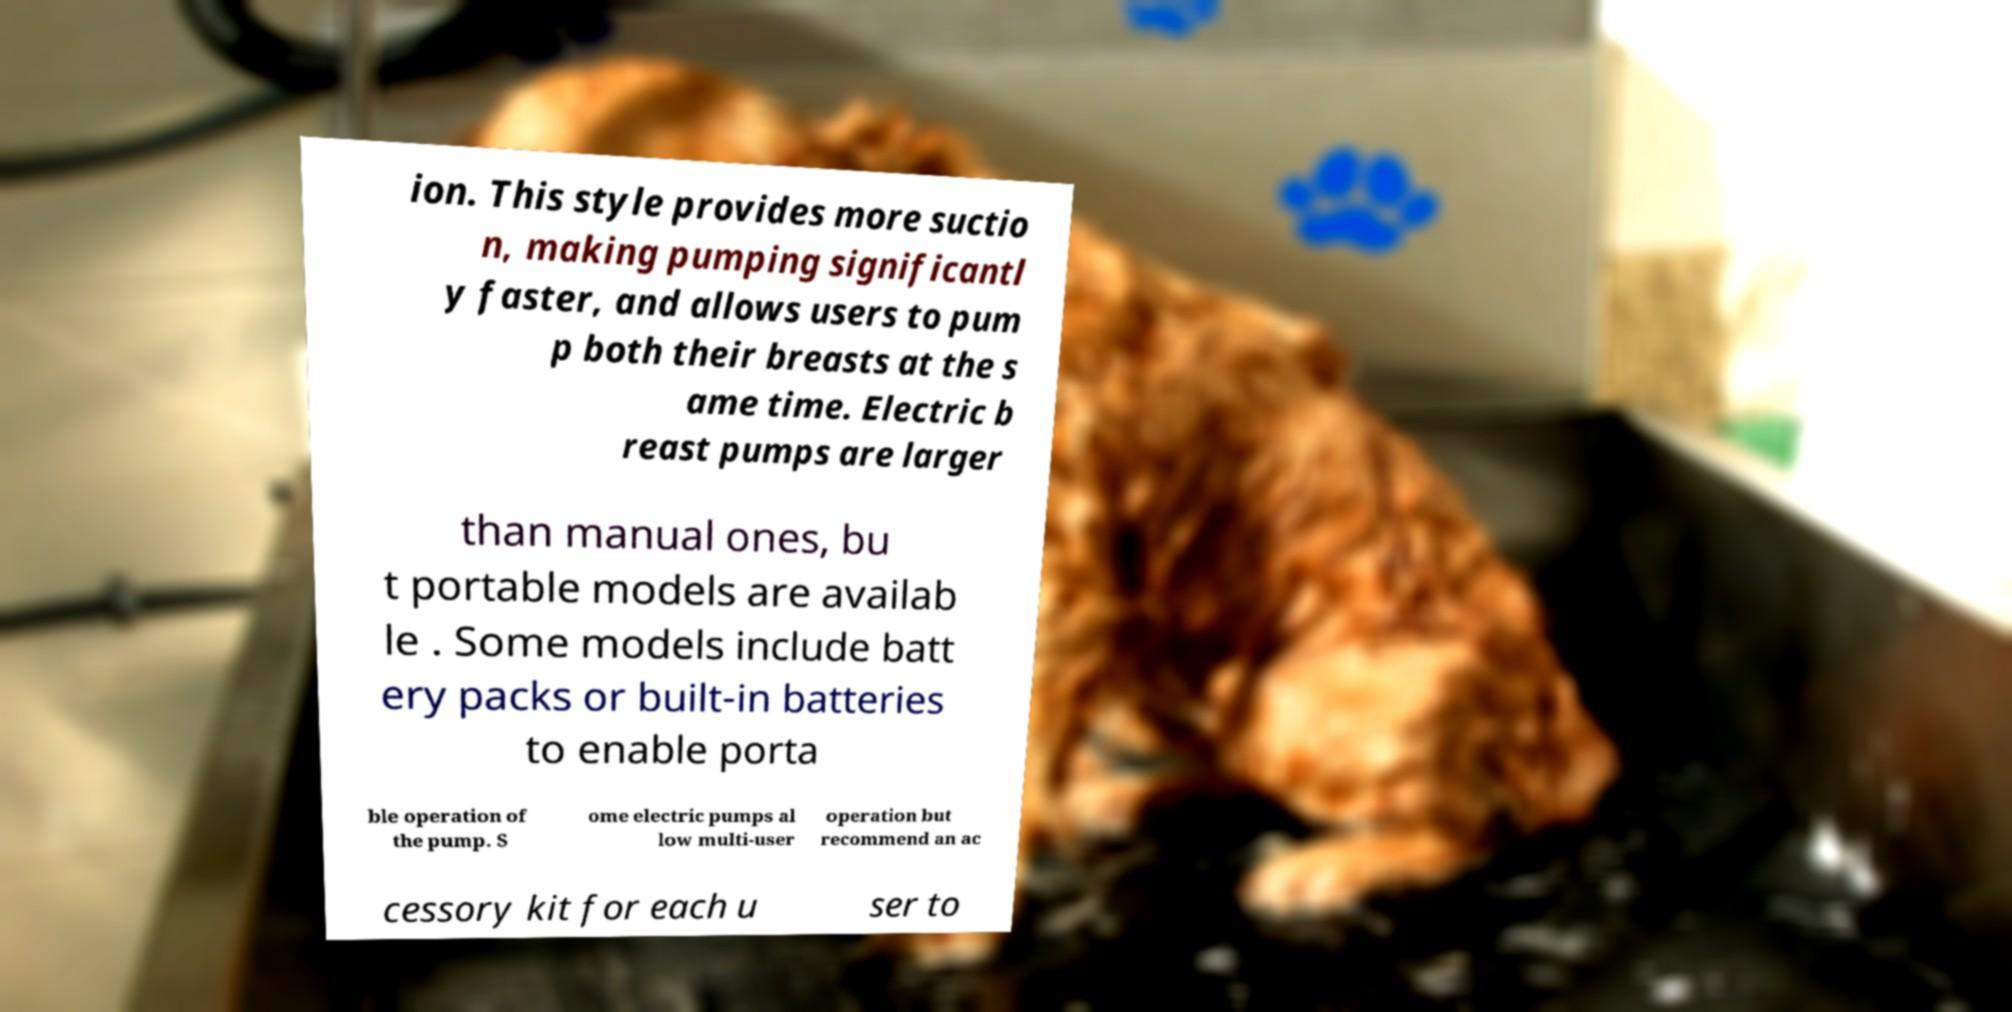Please read and relay the text visible in this image. What does it say? ion. This style provides more suctio n, making pumping significantl y faster, and allows users to pum p both their breasts at the s ame time. Electric b reast pumps are larger than manual ones, bu t portable models are availab le . Some models include batt ery packs or built-in batteries to enable porta ble operation of the pump. S ome electric pumps al low multi-user operation but recommend an ac cessory kit for each u ser to 